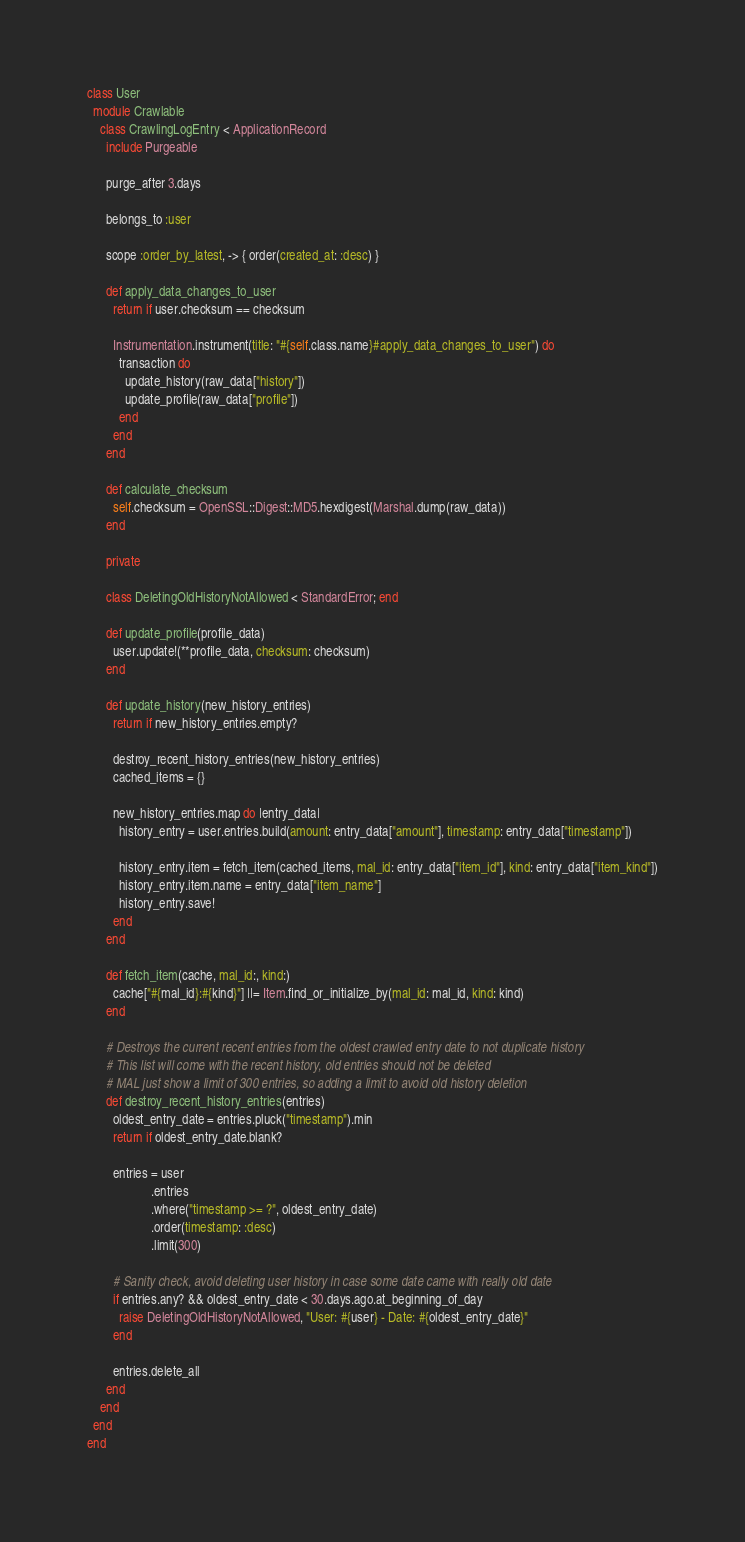Convert code to text. <code><loc_0><loc_0><loc_500><loc_500><_Ruby_>class User
  module Crawlable
    class CrawlingLogEntry < ApplicationRecord
      include Purgeable

      purge_after 3.days

      belongs_to :user

      scope :order_by_latest, -> { order(created_at: :desc) }

      def apply_data_changes_to_user
        return if user.checksum == checksum

        Instrumentation.instrument(title: "#{self.class.name}#apply_data_changes_to_user") do
          transaction do
            update_history(raw_data["history"])
            update_profile(raw_data["profile"])
          end
        end
      end

      def calculate_checksum
        self.checksum = OpenSSL::Digest::MD5.hexdigest(Marshal.dump(raw_data))
      end

      private

      class DeletingOldHistoryNotAllowed < StandardError; end

      def update_profile(profile_data)
        user.update!(**profile_data, checksum: checksum)
      end

      def update_history(new_history_entries)
        return if new_history_entries.empty?

        destroy_recent_history_entries(new_history_entries)
        cached_items = {}

        new_history_entries.map do |entry_data|
          history_entry = user.entries.build(amount: entry_data["amount"], timestamp: entry_data["timestamp"])

          history_entry.item = fetch_item(cached_items, mal_id: entry_data["item_id"], kind: entry_data["item_kind"])
          history_entry.item.name = entry_data["item_name"]
          history_entry.save!
        end
      end

      def fetch_item(cache, mal_id:, kind:)
        cache["#{mal_id}:#{kind}"] ||= Item.find_or_initialize_by(mal_id: mal_id, kind: kind)
      end

      # Destroys the current recent entries from the oldest crawled entry date to not duplicate history
      # This list will come with the recent history, old entries should not be deleted
      # MAL just show a limit of 300 entries, so adding a limit to avoid old history deletion
      def destroy_recent_history_entries(entries)
        oldest_entry_date = entries.pluck("timestamp").min
        return if oldest_entry_date.blank?

        entries = user
                    .entries
                    .where("timestamp >= ?", oldest_entry_date)
                    .order(timestamp: :desc)
                    .limit(300)

        # Sanity check, avoid deleting user history in case some date came with really old date
        if entries.any? && oldest_entry_date < 30.days.ago.at_beginning_of_day
          raise DeletingOldHistoryNotAllowed, "User: #{user} - Date: #{oldest_entry_date}"
        end

        entries.delete_all
      end
    end
  end
end
</code> 